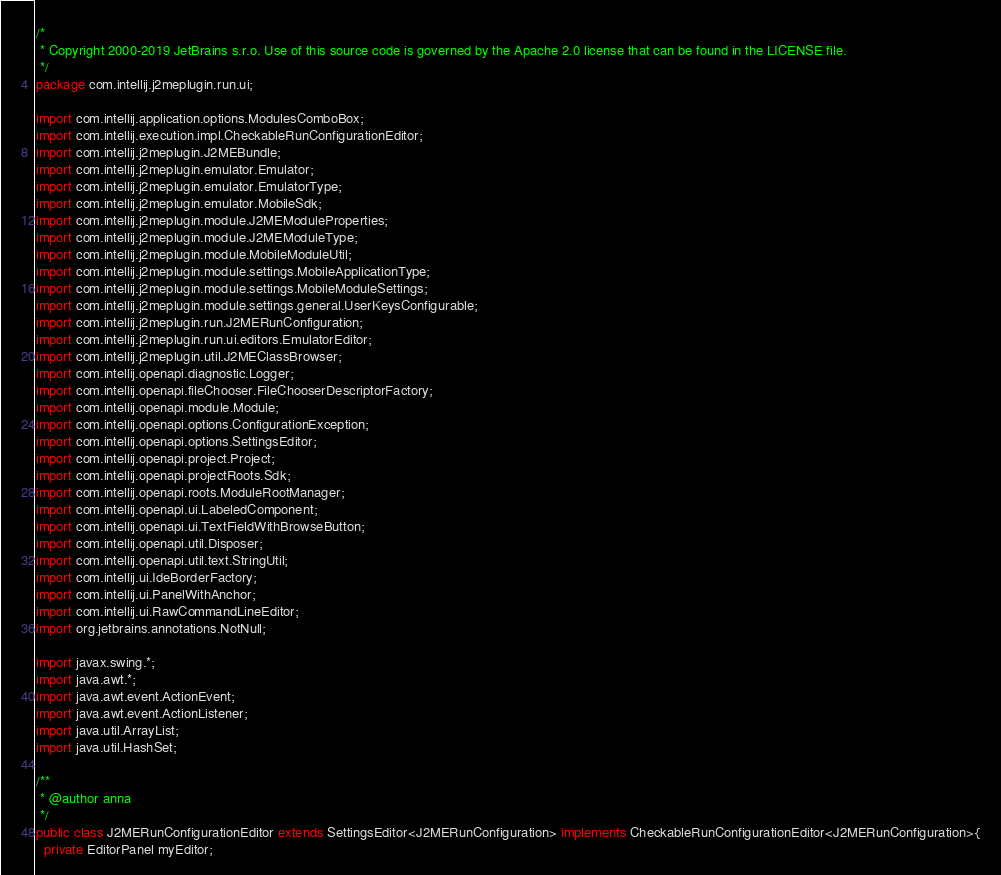<code> <loc_0><loc_0><loc_500><loc_500><_Java_>/*
 * Copyright 2000-2019 JetBrains s.r.o. Use of this source code is governed by the Apache 2.0 license that can be found in the LICENSE file.
 */
package com.intellij.j2meplugin.run.ui;

import com.intellij.application.options.ModulesComboBox;
import com.intellij.execution.impl.CheckableRunConfigurationEditor;
import com.intellij.j2meplugin.J2MEBundle;
import com.intellij.j2meplugin.emulator.Emulator;
import com.intellij.j2meplugin.emulator.EmulatorType;
import com.intellij.j2meplugin.emulator.MobileSdk;
import com.intellij.j2meplugin.module.J2MEModuleProperties;
import com.intellij.j2meplugin.module.J2MEModuleType;
import com.intellij.j2meplugin.module.MobileModuleUtil;
import com.intellij.j2meplugin.module.settings.MobileApplicationType;
import com.intellij.j2meplugin.module.settings.MobileModuleSettings;
import com.intellij.j2meplugin.module.settings.general.UserKeysConfigurable;
import com.intellij.j2meplugin.run.J2MERunConfiguration;
import com.intellij.j2meplugin.run.ui.editors.EmulatorEditor;
import com.intellij.j2meplugin.util.J2MEClassBrowser;
import com.intellij.openapi.diagnostic.Logger;
import com.intellij.openapi.fileChooser.FileChooserDescriptorFactory;
import com.intellij.openapi.module.Module;
import com.intellij.openapi.options.ConfigurationException;
import com.intellij.openapi.options.SettingsEditor;
import com.intellij.openapi.project.Project;
import com.intellij.openapi.projectRoots.Sdk;
import com.intellij.openapi.roots.ModuleRootManager;
import com.intellij.openapi.ui.LabeledComponent;
import com.intellij.openapi.ui.TextFieldWithBrowseButton;
import com.intellij.openapi.util.Disposer;
import com.intellij.openapi.util.text.StringUtil;
import com.intellij.ui.IdeBorderFactory;
import com.intellij.ui.PanelWithAnchor;
import com.intellij.ui.RawCommandLineEditor;
import org.jetbrains.annotations.NotNull;

import javax.swing.*;
import java.awt.*;
import java.awt.event.ActionEvent;
import java.awt.event.ActionListener;
import java.util.ArrayList;
import java.util.HashSet;

/**
 * @author anna
 */
public class J2MERunConfigurationEditor extends SettingsEditor<J2MERunConfiguration> implements CheckableRunConfigurationEditor<J2MERunConfiguration>{
  private EditorPanel myEditor;</code> 